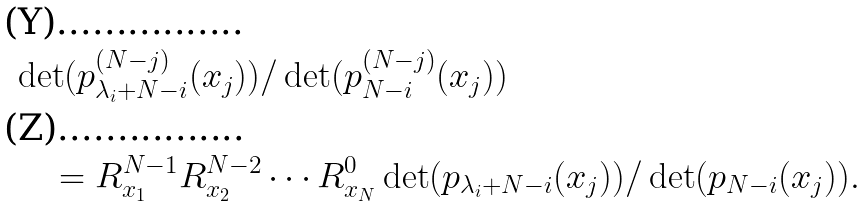Convert formula to latex. <formula><loc_0><loc_0><loc_500><loc_500>& \det ( p ^ { ( N - j ) } _ { \lambda _ { i } + N - i } ( x _ { j } ) ) / \det ( p ^ { ( N - j ) } _ { N - i } ( x _ { j } ) ) \\ & \quad = R _ { x _ { 1 } } ^ { N - 1 } R _ { x _ { 2 } } ^ { N - 2 } \cdots R _ { x _ { N } } ^ { 0 } \det ( p _ { \lambda _ { i } + N - i } ( x _ { j } ) ) / \det ( p _ { N - i } ( x _ { j } ) ) .</formula> 